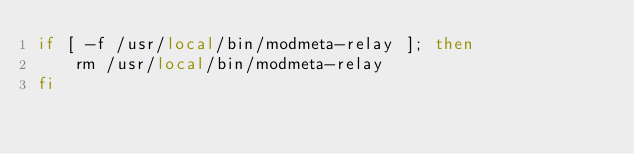Convert code to text. <code><loc_0><loc_0><loc_500><loc_500><_Bash_>if [ -f /usr/local/bin/modmeta-relay ]; then
    rm /usr/local/bin/modmeta-relay
fi</code> 